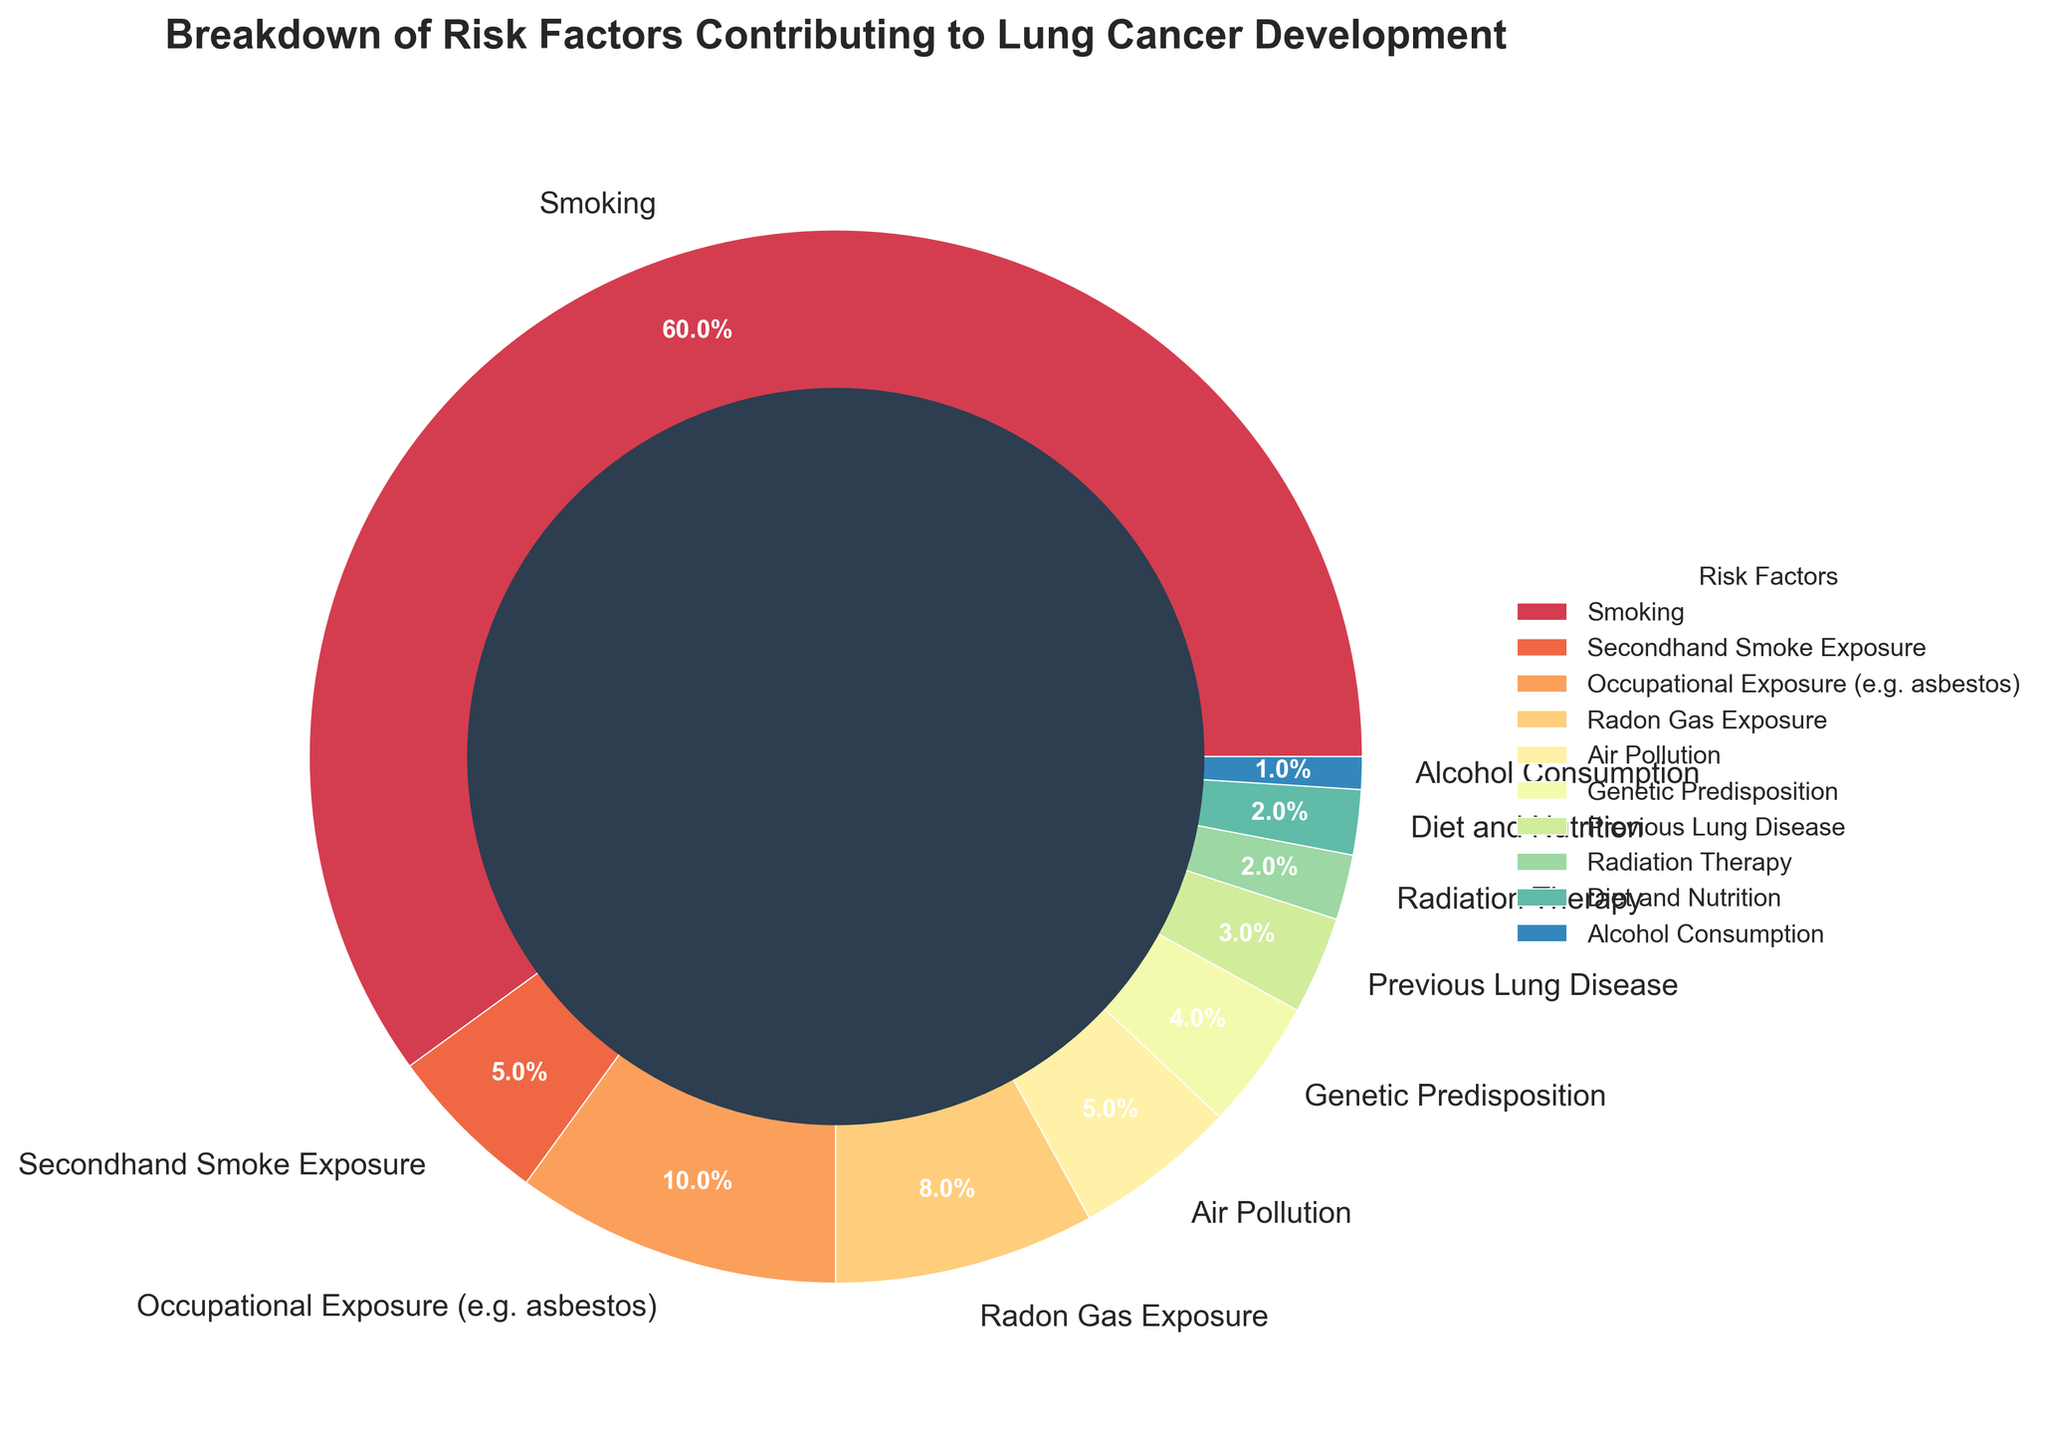Which risk factor contributes the most to lung cancer development? The pie chart shows the contribution of different risk factors to lung cancer development. The largest segment is for Smoking.
Answer: Smoking What percentage of lung cancer cases is attributed to Occupational Exposure and Radon Gas Exposure combined? The figure lists Occupational Exposure as contributing 10% and Radon Gas Exposure as 8%. Adding these percentages: 10% + 8% = 18%.
Answer: 18% Are there any risk factors that contribute equally to lung cancer development? If so, which ones? Looking at the pie chart, both Secondhand Smoke Exposure and Air Pollution each contribute 5% to lung cancer development.
Answer: Secondhand Smoke Exposure and Air Pollution Which risk factor contributes the least to lung cancer development and what is its percentage? The smallest segment in the pie chart represents Alcohol Consumption, contributing 1%.
Answer: Alcohol Consumption, 1% How does the percentage of lung cancer cases attributed to Genetic Predisposition compare to that from Previous Lung Disease? The pie chart shows that Genetic Predisposition contributes 4% and Previous Lung Disease 3%, so Genetic Predisposition contributes 1% more.
Answer: Genetic Predisposition contributes 1% more What is the total percentage of lung cancer cases attributed to non-smoking-related risk factors? Excluding smoking (60%), sum the other percentages: 5 + 10 + 8 + 5 + 4 + 3 + 2 + 2 + 1 = 40%.
Answer: 40% Which risk factor represented by a segment in the pie chart is closest in color to blue, and what is its percentage? Observing the colors in the pie chart, the segment for Radon Gas Exposure appears to have the color closest to blue and contributes 8%.
Answer: Radon Gas Exposure, 8% Which three risk factors contribute the most to lung cancer development and what are their combined percentages? The three largest segments are Smoking (60%), Occupational Exposure (10%), and Radon Gas Exposure (8%). Adding these percentages: 60% + 10% + 8% = 78%.
Answer: Smoking, Occupational Exposure, and Radon Gas Exposure; 78% Between Radiation Therapy and Diet and Nutrition, which has a greater contribution to lung cancer development and by how much? The pie chart lists Radiation Therapy at 2% and Diet and Nutrition also at 2%. Thus, their contributions are equal.
Answer: They are equal What is the ratio of the percentage of lung cancer cases due to Smoking to the percentage due to Air Pollution? Smoking contributes 60% while Air Pollution contributes 5%. The ratio is 60:5, which simplifies to 12:1.
Answer: 12:1 